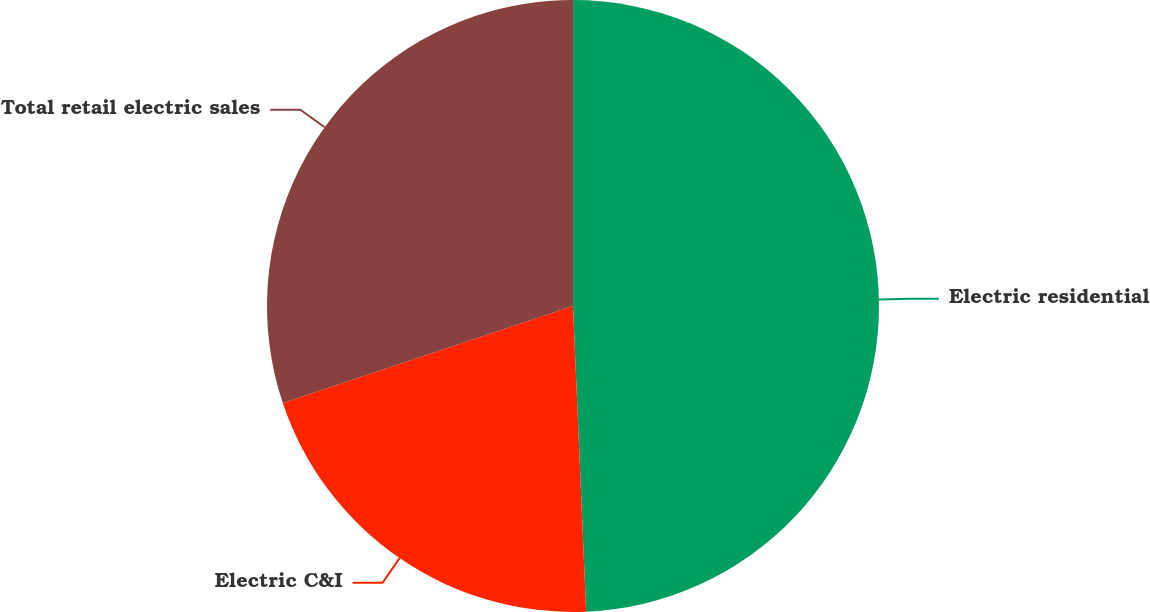<chart> <loc_0><loc_0><loc_500><loc_500><pie_chart><fcel>Electric residential<fcel>Electric C&I<fcel>Total retail electric sales<nl><fcel>49.32%<fcel>20.55%<fcel>30.14%<nl></chart> 